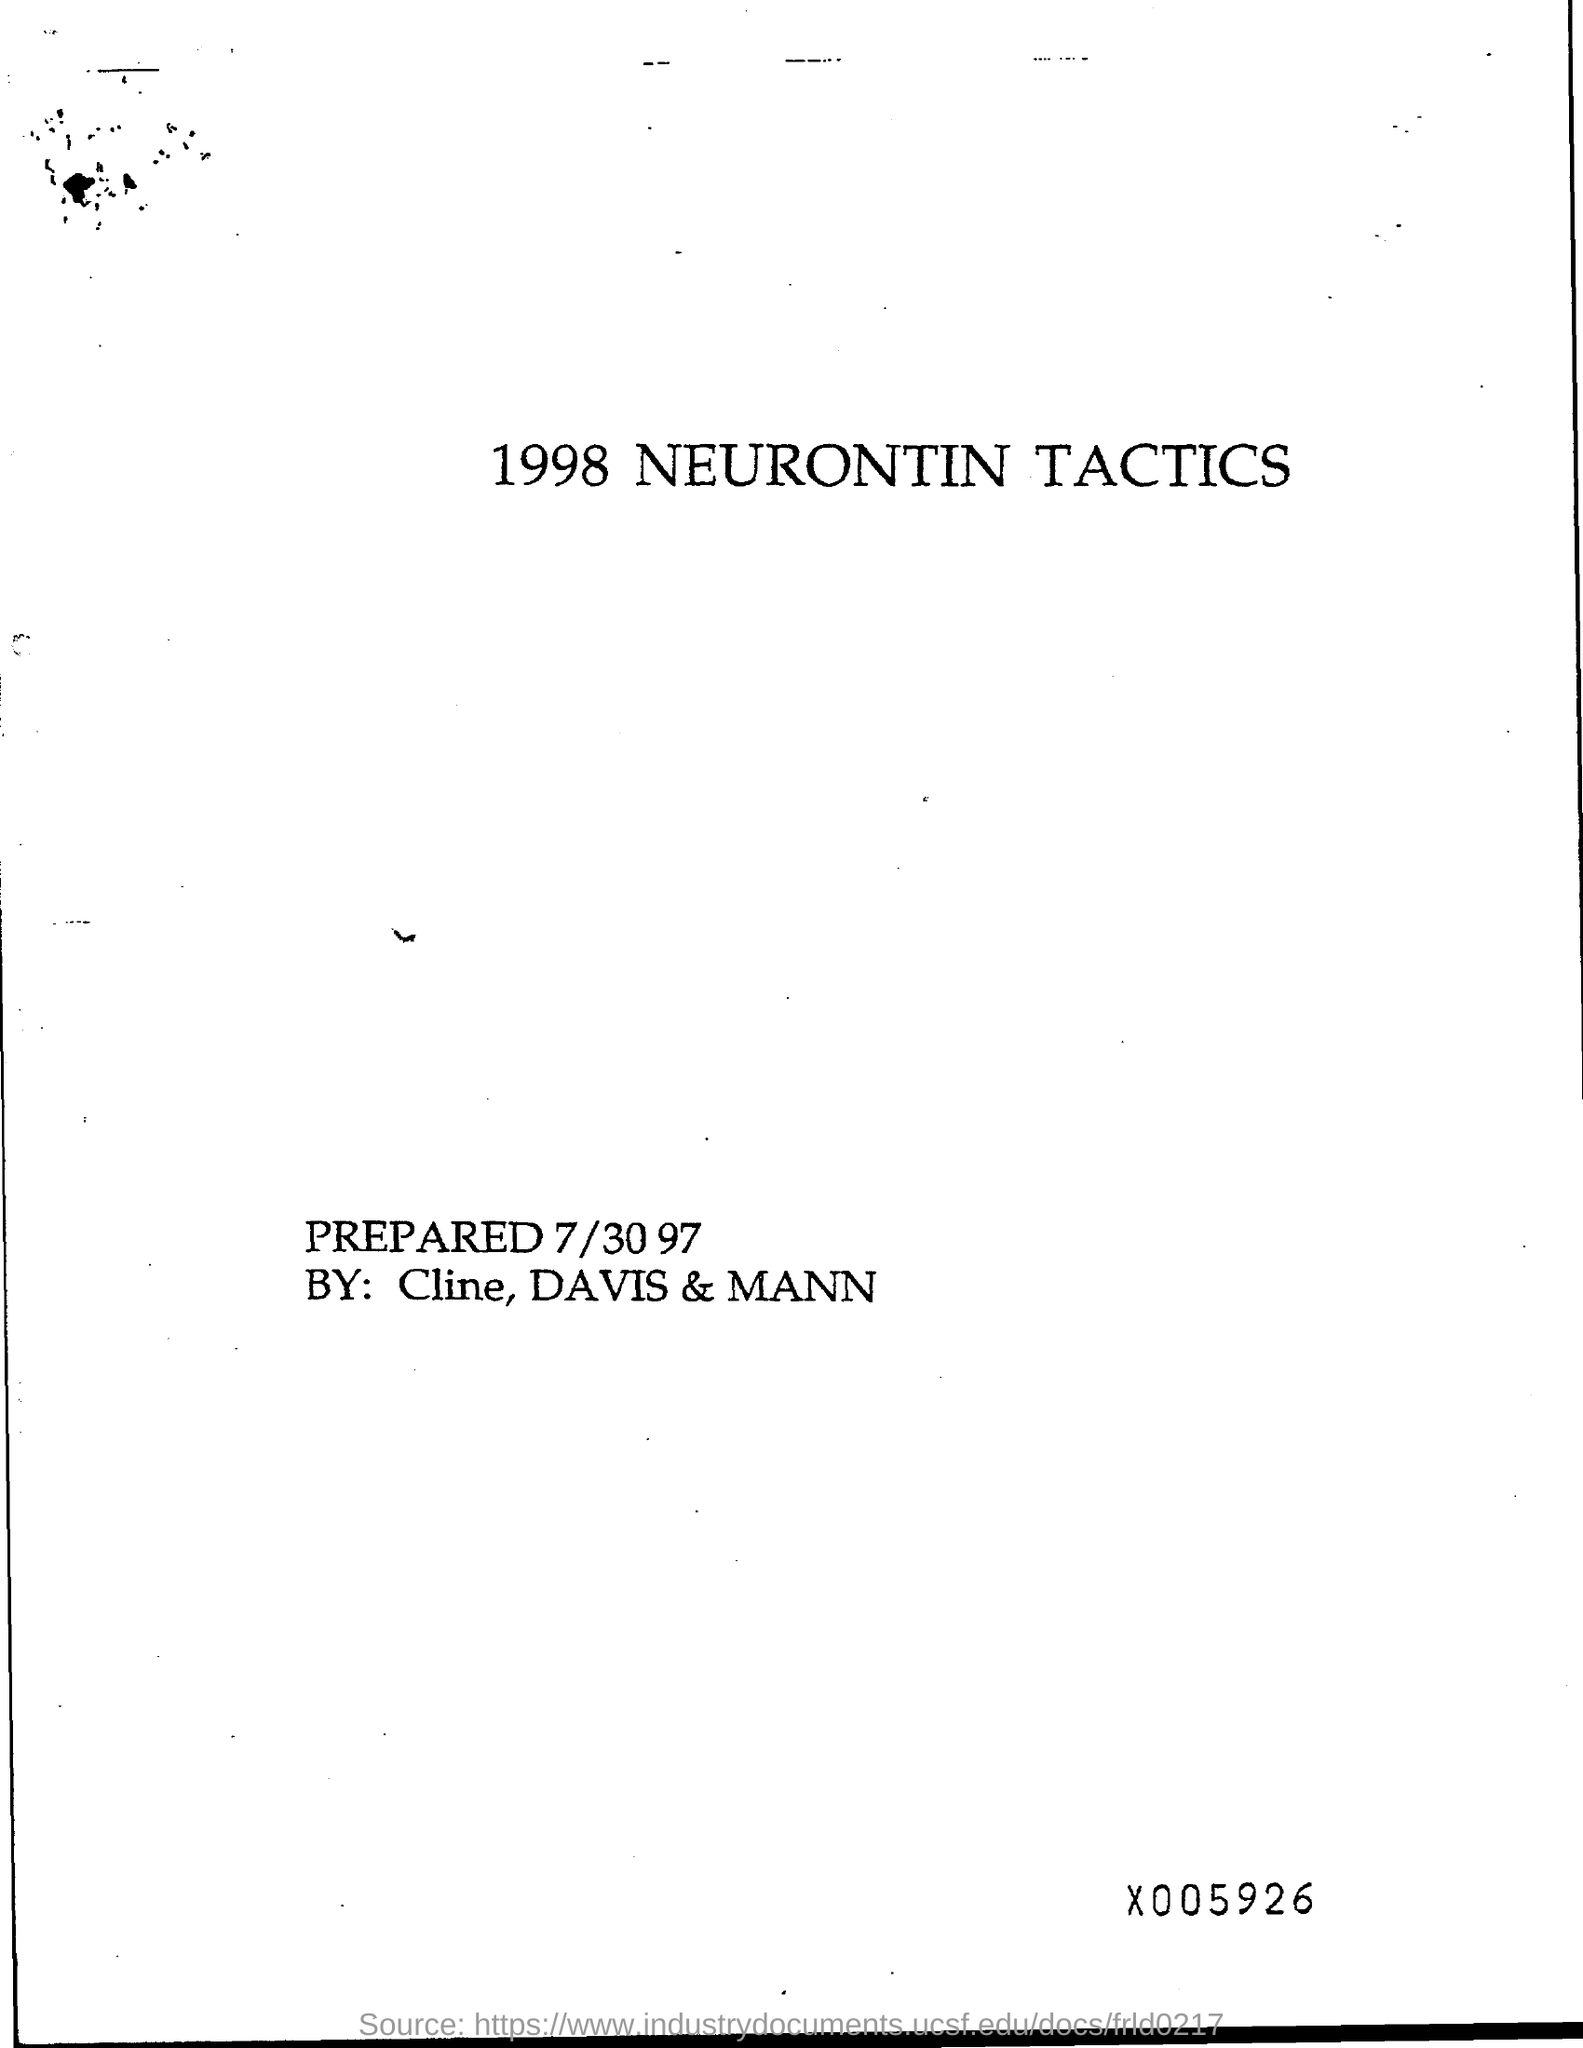Outline some significant characteristics in this image. The date on the page is July 30, 1997. 